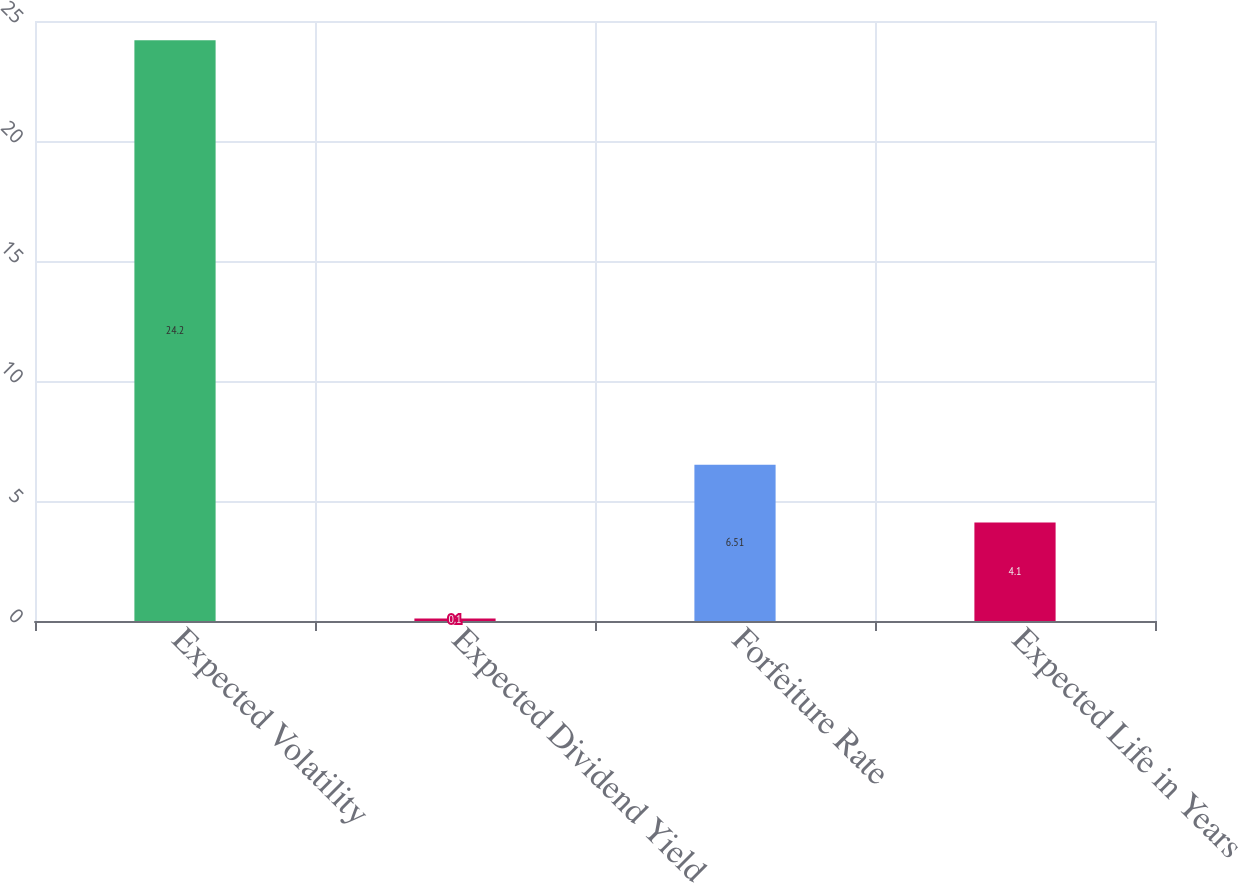Convert chart to OTSL. <chart><loc_0><loc_0><loc_500><loc_500><bar_chart><fcel>Expected Volatility<fcel>Expected Dividend Yield<fcel>Forfeiture Rate<fcel>Expected Life in Years<nl><fcel>24.2<fcel>0.1<fcel>6.51<fcel>4.1<nl></chart> 